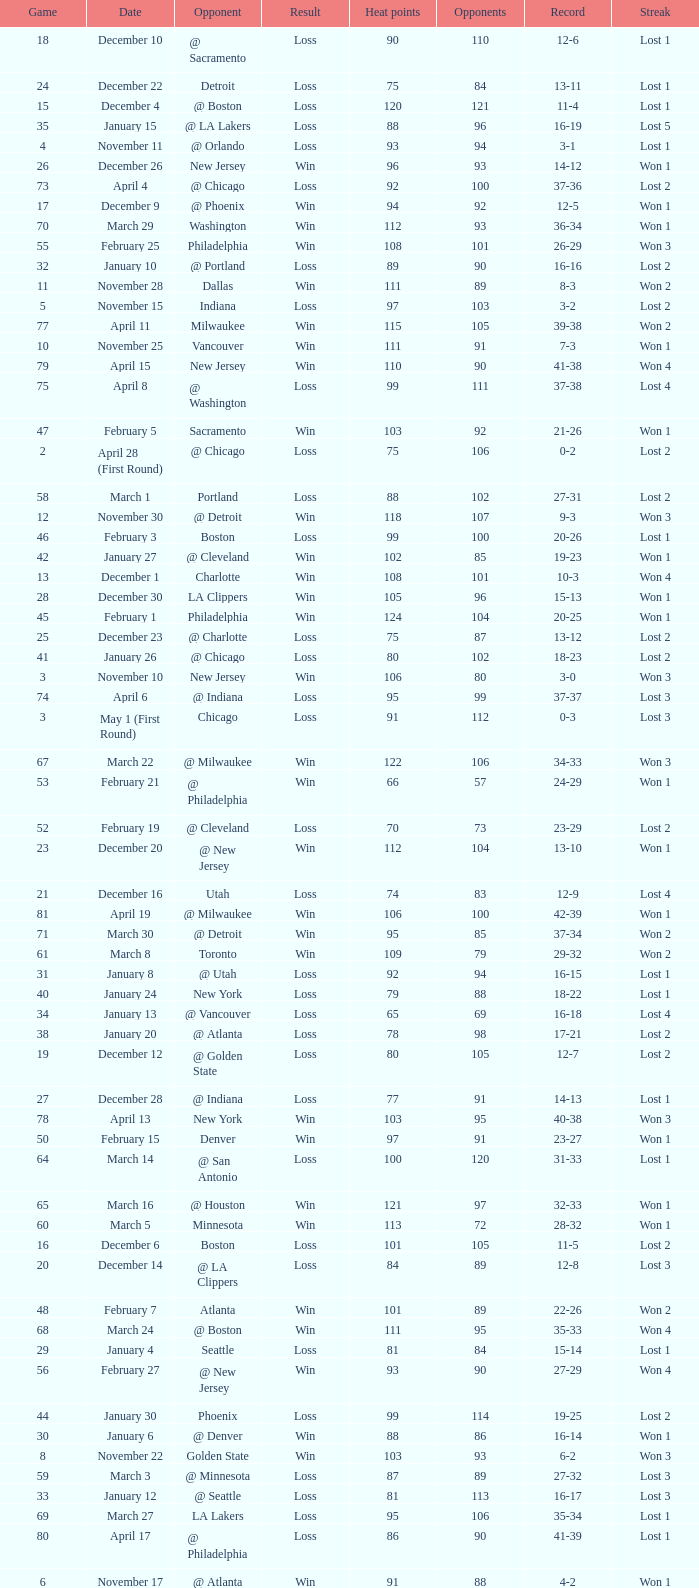What is Result, when Date is "December 12"? Loss. 